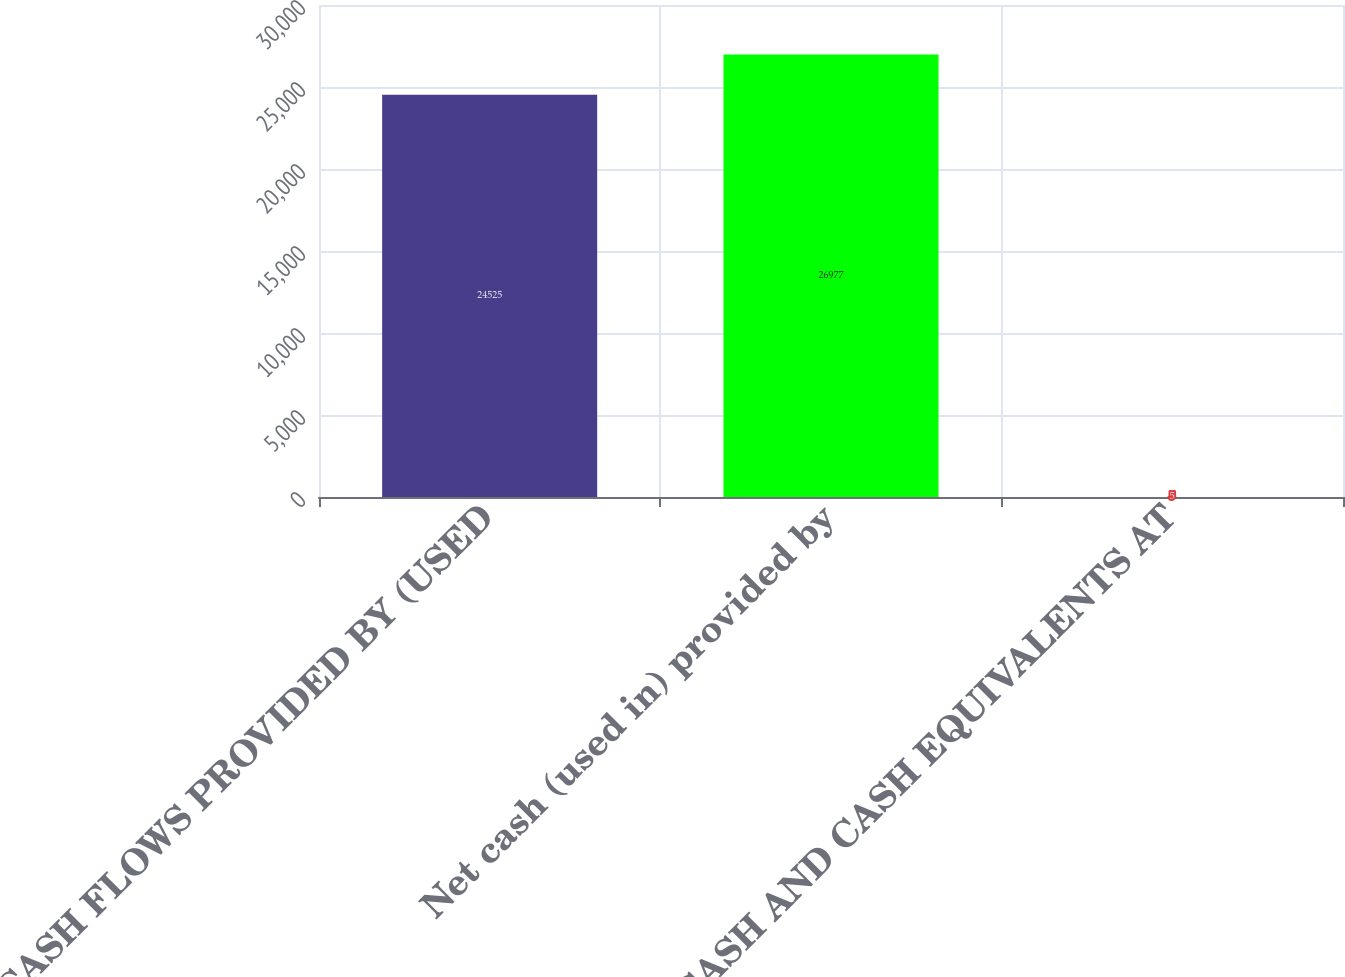<chart> <loc_0><loc_0><loc_500><loc_500><bar_chart><fcel>CASH FLOWS PROVIDED BY (USED<fcel>Net cash (used in) provided by<fcel>CASH AND CASH EQUIVALENTS AT<nl><fcel>24525<fcel>26977<fcel>5<nl></chart> 